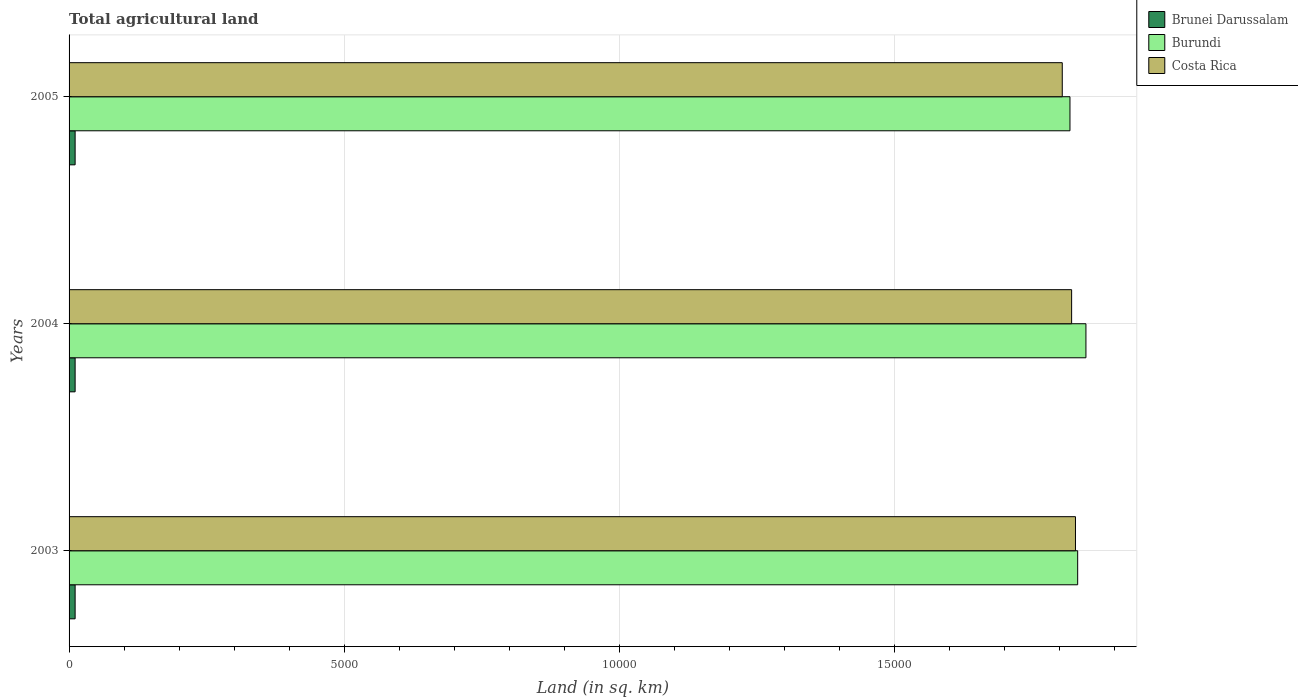How many groups of bars are there?
Give a very brief answer. 3. How many bars are there on the 3rd tick from the top?
Your response must be concise. 3. How many bars are there on the 2nd tick from the bottom?
Provide a short and direct response. 3. In how many cases, is the number of bars for a given year not equal to the number of legend labels?
Provide a succinct answer. 0. What is the total agricultural land in Costa Rica in 2003?
Keep it short and to the point. 1.83e+04. Across all years, what is the maximum total agricultural land in Costa Rica?
Offer a terse response. 1.83e+04. Across all years, what is the minimum total agricultural land in Costa Rica?
Offer a terse response. 1.80e+04. In which year was the total agricultural land in Burundi maximum?
Your answer should be very brief. 2004. What is the total total agricultural land in Brunei Darussalam in the graph?
Keep it short and to the point. 330. What is the difference between the total agricultural land in Burundi in 2003 and that in 2004?
Provide a succinct answer. -150. What is the difference between the total agricultural land in Burundi in 2004 and the total agricultural land in Brunei Darussalam in 2003?
Offer a terse response. 1.84e+04. What is the average total agricultural land in Costa Rica per year?
Your answer should be very brief. 1.82e+04. In the year 2004, what is the difference between the total agricultural land in Burundi and total agricultural land in Brunei Darussalam?
Give a very brief answer. 1.84e+04. In how many years, is the total agricultural land in Costa Rica greater than 18000 sq.km?
Keep it short and to the point. 3. What is the ratio of the total agricultural land in Brunei Darussalam in 2004 to that in 2005?
Ensure brevity in your answer.  1. Is the total agricultural land in Costa Rica in 2004 less than that in 2005?
Your response must be concise. No. Is the difference between the total agricultural land in Burundi in 2003 and 2005 greater than the difference between the total agricultural land in Brunei Darussalam in 2003 and 2005?
Ensure brevity in your answer.  Yes. What is the difference between the highest and the second highest total agricultural land in Costa Rica?
Your response must be concise. 70. What does the 2nd bar from the top in 2003 represents?
Your answer should be compact. Burundi. What does the 1st bar from the bottom in 2004 represents?
Offer a very short reply. Brunei Darussalam. How many bars are there?
Your answer should be very brief. 9. Are all the bars in the graph horizontal?
Your answer should be compact. Yes. What is the difference between two consecutive major ticks on the X-axis?
Your answer should be compact. 5000. Where does the legend appear in the graph?
Offer a very short reply. Top right. How many legend labels are there?
Your response must be concise. 3. How are the legend labels stacked?
Give a very brief answer. Vertical. What is the title of the graph?
Make the answer very short. Total agricultural land. Does "Cabo Verde" appear as one of the legend labels in the graph?
Your response must be concise. No. What is the label or title of the X-axis?
Keep it short and to the point. Land (in sq. km). What is the Land (in sq. km) of Brunei Darussalam in 2003?
Provide a short and direct response. 110. What is the Land (in sq. km) in Burundi in 2003?
Provide a succinct answer. 1.83e+04. What is the Land (in sq. km) in Costa Rica in 2003?
Make the answer very short. 1.83e+04. What is the Land (in sq. km) of Brunei Darussalam in 2004?
Offer a very short reply. 110. What is the Land (in sq. km) of Burundi in 2004?
Your answer should be compact. 1.85e+04. What is the Land (in sq. km) in Costa Rica in 2004?
Ensure brevity in your answer.  1.82e+04. What is the Land (in sq. km) in Brunei Darussalam in 2005?
Make the answer very short. 110. What is the Land (in sq. km) of Burundi in 2005?
Provide a succinct answer. 1.82e+04. What is the Land (in sq. km) of Costa Rica in 2005?
Make the answer very short. 1.80e+04. Across all years, what is the maximum Land (in sq. km) of Brunei Darussalam?
Give a very brief answer. 110. Across all years, what is the maximum Land (in sq. km) in Burundi?
Keep it short and to the point. 1.85e+04. Across all years, what is the maximum Land (in sq. km) in Costa Rica?
Offer a terse response. 1.83e+04. Across all years, what is the minimum Land (in sq. km) in Brunei Darussalam?
Give a very brief answer. 110. Across all years, what is the minimum Land (in sq. km) in Burundi?
Your answer should be very brief. 1.82e+04. Across all years, what is the minimum Land (in sq. km) of Costa Rica?
Keep it short and to the point. 1.80e+04. What is the total Land (in sq. km) in Brunei Darussalam in the graph?
Make the answer very short. 330. What is the total Land (in sq. km) in Burundi in the graph?
Your answer should be compact. 5.50e+04. What is the total Land (in sq. km) of Costa Rica in the graph?
Your answer should be very brief. 5.46e+04. What is the difference between the Land (in sq. km) in Burundi in 2003 and that in 2004?
Offer a terse response. -150. What is the difference between the Land (in sq. km) of Costa Rica in 2003 and that in 2004?
Give a very brief answer. 70. What is the difference between the Land (in sq. km) of Burundi in 2003 and that in 2005?
Ensure brevity in your answer.  140. What is the difference between the Land (in sq. km) in Costa Rica in 2003 and that in 2005?
Make the answer very short. 240. What is the difference between the Land (in sq. km) of Brunei Darussalam in 2004 and that in 2005?
Your answer should be very brief. 0. What is the difference between the Land (in sq. km) in Burundi in 2004 and that in 2005?
Your answer should be compact. 290. What is the difference between the Land (in sq. km) in Costa Rica in 2004 and that in 2005?
Give a very brief answer. 170. What is the difference between the Land (in sq. km) in Brunei Darussalam in 2003 and the Land (in sq. km) in Burundi in 2004?
Give a very brief answer. -1.84e+04. What is the difference between the Land (in sq. km) of Brunei Darussalam in 2003 and the Land (in sq. km) of Costa Rica in 2004?
Ensure brevity in your answer.  -1.81e+04. What is the difference between the Land (in sq. km) of Burundi in 2003 and the Land (in sq. km) of Costa Rica in 2004?
Provide a short and direct response. 110. What is the difference between the Land (in sq. km) of Brunei Darussalam in 2003 and the Land (in sq. km) of Burundi in 2005?
Ensure brevity in your answer.  -1.81e+04. What is the difference between the Land (in sq. km) in Brunei Darussalam in 2003 and the Land (in sq. km) in Costa Rica in 2005?
Make the answer very short. -1.79e+04. What is the difference between the Land (in sq. km) in Burundi in 2003 and the Land (in sq. km) in Costa Rica in 2005?
Provide a short and direct response. 280. What is the difference between the Land (in sq. km) of Brunei Darussalam in 2004 and the Land (in sq. km) of Burundi in 2005?
Offer a terse response. -1.81e+04. What is the difference between the Land (in sq. km) of Brunei Darussalam in 2004 and the Land (in sq. km) of Costa Rica in 2005?
Your answer should be very brief. -1.79e+04. What is the difference between the Land (in sq. km) in Burundi in 2004 and the Land (in sq. km) in Costa Rica in 2005?
Provide a succinct answer. 430. What is the average Land (in sq. km) in Brunei Darussalam per year?
Keep it short and to the point. 110. What is the average Land (in sq. km) in Burundi per year?
Offer a terse response. 1.83e+04. What is the average Land (in sq. km) in Costa Rica per year?
Provide a short and direct response. 1.82e+04. In the year 2003, what is the difference between the Land (in sq. km) in Brunei Darussalam and Land (in sq. km) in Burundi?
Give a very brief answer. -1.82e+04. In the year 2003, what is the difference between the Land (in sq. km) in Brunei Darussalam and Land (in sq. km) in Costa Rica?
Your response must be concise. -1.82e+04. In the year 2003, what is the difference between the Land (in sq. km) of Burundi and Land (in sq. km) of Costa Rica?
Offer a very short reply. 40. In the year 2004, what is the difference between the Land (in sq. km) in Brunei Darussalam and Land (in sq. km) in Burundi?
Your answer should be compact. -1.84e+04. In the year 2004, what is the difference between the Land (in sq. km) of Brunei Darussalam and Land (in sq. km) of Costa Rica?
Your answer should be very brief. -1.81e+04. In the year 2004, what is the difference between the Land (in sq. km) in Burundi and Land (in sq. km) in Costa Rica?
Give a very brief answer. 260. In the year 2005, what is the difference between the Land (in sq. km) of Brunei Darussalam and Land (in sq. km) of Burundi?
Provide a short and direct response. -1.81e+04. In the year 2005, what is the difference between the Land (in sq. km) of Brunei Darussalam and Land (in sq. km) of Costa Rica?
Keep it short and to the point. -1.79e+04. In the year 2005, what is the difference between the Land (in sq. km) of Burundi and Land (in sq. km) of Costa Rica?
Your answer should be very brief. 140. What is the ratio of the Land (in sq. km) of Burundi in 2003 to that in 2004?
Provide a short and direct response. 0.99. What is the ratio of the Land (in sq. km) in Burundi in 2003 to that in 2005?
Make the answer very short. 1.01. What is the ratio of the Land (in sq. km) in Costa Rica in 2003 to that in 2005?
Make the answer very short. 1.01. What is the ratio of the Land (in sq. km) in Burundi in 2004 to that in 2005?
Provide a short and direct response. 1.02. What is the ratio of the Land (in sq. km) in Costa Rica in 2004 to that in 2005?
Provide a succinct answer. 1.01. What is the difference between the highest and the second highest Land (in sq. km) of Burundi?
Ensure brevity in your answer.  150. What is the difference between the highest and the second highest Land (in sq. km) in Costa Rica?
Make the answer very short. 70. What is the difference between the highest and the lowest Land (in sq. km) of Burundi?
Ensure brevity in your answer.  290. What is the difference between the highest and the lowest Land (in sq. km) of Costa Rica?
Offer a terse response. 240. 